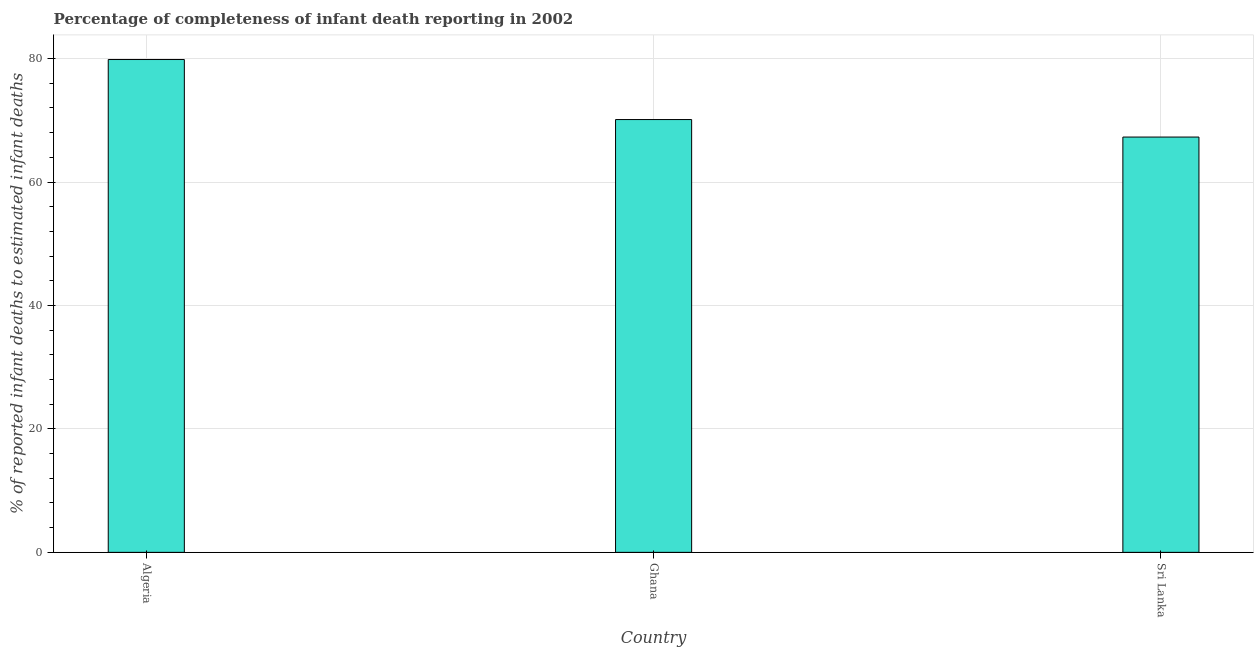Does the graph contain grids?
Provide a short and direct response. Yes. What is the title of the graph?
Make the answer very short. Percentage of completeness of infant death reporting in 2002. What is the label or title of the Y-axis?
Your answer should be compact. % of reported infant deaths to estimated infant deaths. What is the completeness of infant death reporting in Ghana?
Offer a very short reply. 70.12. Across all countries, what is the maximum completeness of infant death reporting?
Your answer should be compact. 79.84. Across all countries, what is the minimum completeness of infant death reporting?
Provide a succinct answer. 67.28. In which country was the completeness of infant death reporting maximum?
Ensure brevity in your answer.  Algeria. In which country was the completeness of infant death reporting minimum?
Ensure brevity in your answer.  Sri Lanka. What is the sum of the completeness of infant death reporting?
Your answer should be very brief. 217.24. What is the difference between the completeness of infant death reporting in Algeria and Ghana?
Give a very brief answer. 9.73. What is the average completeness of infant death reporting per country?
Your answer should be very brief. 72.42. What is the median completeness of infant death reporting?
Ensure brevity in your answer.  70.12. In how many countries, is the completeness of infant death reporting greater than 72 %?
Offer a very short reply. 1. What is the ratio of the completeness of infant death reporting in Algeria to that in Sri Lanka?
Offer a very short reply. 1.19. Is the difference between the completeness of infant death reporting in Algeria and Ghana greater than the difference between any two countries?
Your answer should be compact. No. What is the difference between the highest and the second highest completeness of infant death reporting?
Ensure brevity in your answer.  9.73. Is the sum of the completeness of infant death reporting in Ghana and Sri Lanka greater than the maximum completeness of infant death reporting across all countries?
Your answer should be very brief. Yes. What is the difference between the highest and the lowest completeness of infant death reporting?
Offer a very short reply. 12.56. In how many countries, is the completeness of infant death reporting greater than the average completeness of infant death reporting taken over all countries?
Ensure brevity in your answer.  1. Are all the bars in the graph horizontal?
Provide a succinct answer. No. How many countries are there in the graph?
Offer a terse response. 3. What is the difference between two consecutive major ticks on the Y-axis?
Give a very brief answer. 20. What is the % of reported infant deaths to estimated infant deaths of Algeria?
Ensure brevity in your answer.  79.84. What is the % of reported infant deaths to estimated infant deaths in Ghana?
Keep it short and to the point. 70.12. What is the % of reported infant deaths to estimated infant deaths in Sri Lanka?
Offer a terse response. 67.28. What is the difference between the % of reported infant deaths to estimated infant deaths in Algeria and Ghana?
Provide a succinct answer. 9.73. What is the difference between the % of reported infant deaths to estimated infant deaths in Algeria and Sri Lanka?
Your answer should be very brief. 12.56. What is the difference between the % of reported infant deaths to estimated infant deaths in Ghana and Sri Lanka?
Keep it short and to the point. 2.83. What is the ratio of the % of reported infant deaths to estimated infant deaths in Algeria to that in Ghana?
Provide a short and direct response. 1.14. What is the ratio of the % of reported infant deaths to estimated infant deaths in Algeria to that in Sri Lanka?
Provide a succinct answer. 1.19. What is the ratio of the % of reported infant deaths to estimated infant deaths in Ghana to that in Sri Lanka?
Offer a very short reply. 1.04. 